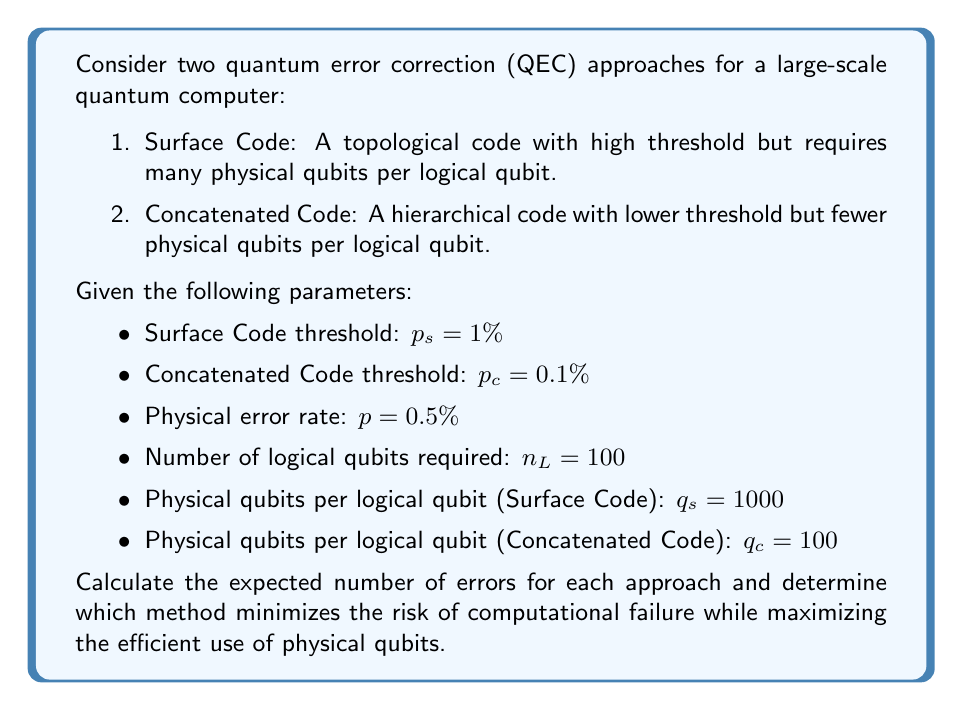Show me your answer to this math problem. To solve this problem, we need to evaluate the risk-reward tradeoff between the two QEC approaches. We'll do this by calculating the expected number of errors for each method and comparing their resource requirements.

1. Surface Code:
The probability of a logical error in the Surface Code is given by:

$$P_L^s = A \left(\frac{p}{p_s}\right)^{d/2}$$

where $A$ is a constant (typically around 0.1), $p$ is the physical error rate, $p_s$ is the threshold, and $d$ is the code distance. We don't have $d$ explicitly, but we can estimate it based on the number of physical qubits per logical qubit:

$$q_s \approx d^2$$

So, $d \approx \sqrt{q_s} = \sqrt{1000} \approx 31.6$

Now we can calculate the logical error probability:

$$P_L^s \approx 0.1 \left(\frac{0.005}{0.01}\right)^{31.6/2} \approx 1.86 \times 10^{-8}$$

The expected number of errors for 100 logical qubits is:

$$E_s = n_L \cdot P_L^s = 100 \cdot 1.86 \times 10^{-8} \approx 1.86 \times 10^{-6}$$

Total physical qubits required: $100 \cdot 1000 = 100,000$

2. Concatenated Code:
For concatenated codes, the logical error probability after $l$ levels of concatenation is approximately:

$$P_L^c = \left(\frac{p}{p_c}\right)^{2^l}$$

We need to determine $l$ based on the number of physical qubits per logical qubit:

$$q_c = 7^l$$

Solving for $l$: $l = \log_7(100) \approx 2.41$

We'll use $l = 3$ levels of concatenation to ensure sufficient error suppression.

Now we can calculate the logical error probability:

$$P_L^c = \left(\frac{0.005}{0.001}\right)^{2^3} \approx 3.91 \times 10^{-7}$$

The expected number of errors for 100 logical qubits is:

$$E_c = n_L \cdot P_L^c = 100 \cdot 3.91 \times 10^{-7} \approx 3.91 \times 10^{-5}$$

Total physical qubits required: $100 \cdot 100 = 10,000$

Comparing the two approaches:
1. Surface Code: $E_s \approx 1.86 \times 10^{-6}$ errors, 100,000 physical qubits
2. Concatenated Code: $E_c \approx 3.91 \times 10^{-5}$ errors, 10,000 physical qubits

The Surface Code has a lower expected number of errors (lower risk) but requires 10 times more physical qubits. The Concatenated Code has a higher expected number of errors (higher risk) but uses fewer physical qubits (better resource efficiency).
Answer: The Surface Code minimizes the risk of computational failure with an expected $1.86 \times 10^{-6}$ errors, while the Concatenated Code maximizes the efficient use of physical qubits, requiring only 10,000 qubits compared to 100,000 for the Surface Code. The choice between the two approaches depends on whether minimizing errors or maximizing resource efficiency is the primary concern for the specific quantum computation task. 